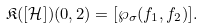<formula> <loc_0><loc_0><loc_500><loc_500>\mathfrak { K } ( [ \mathcal { H } ] ) ( 0 , 2 ) = [ \wp _ { \sigma } ( f _ { 1 } , f _ { 2 } ) ] .</formula> 